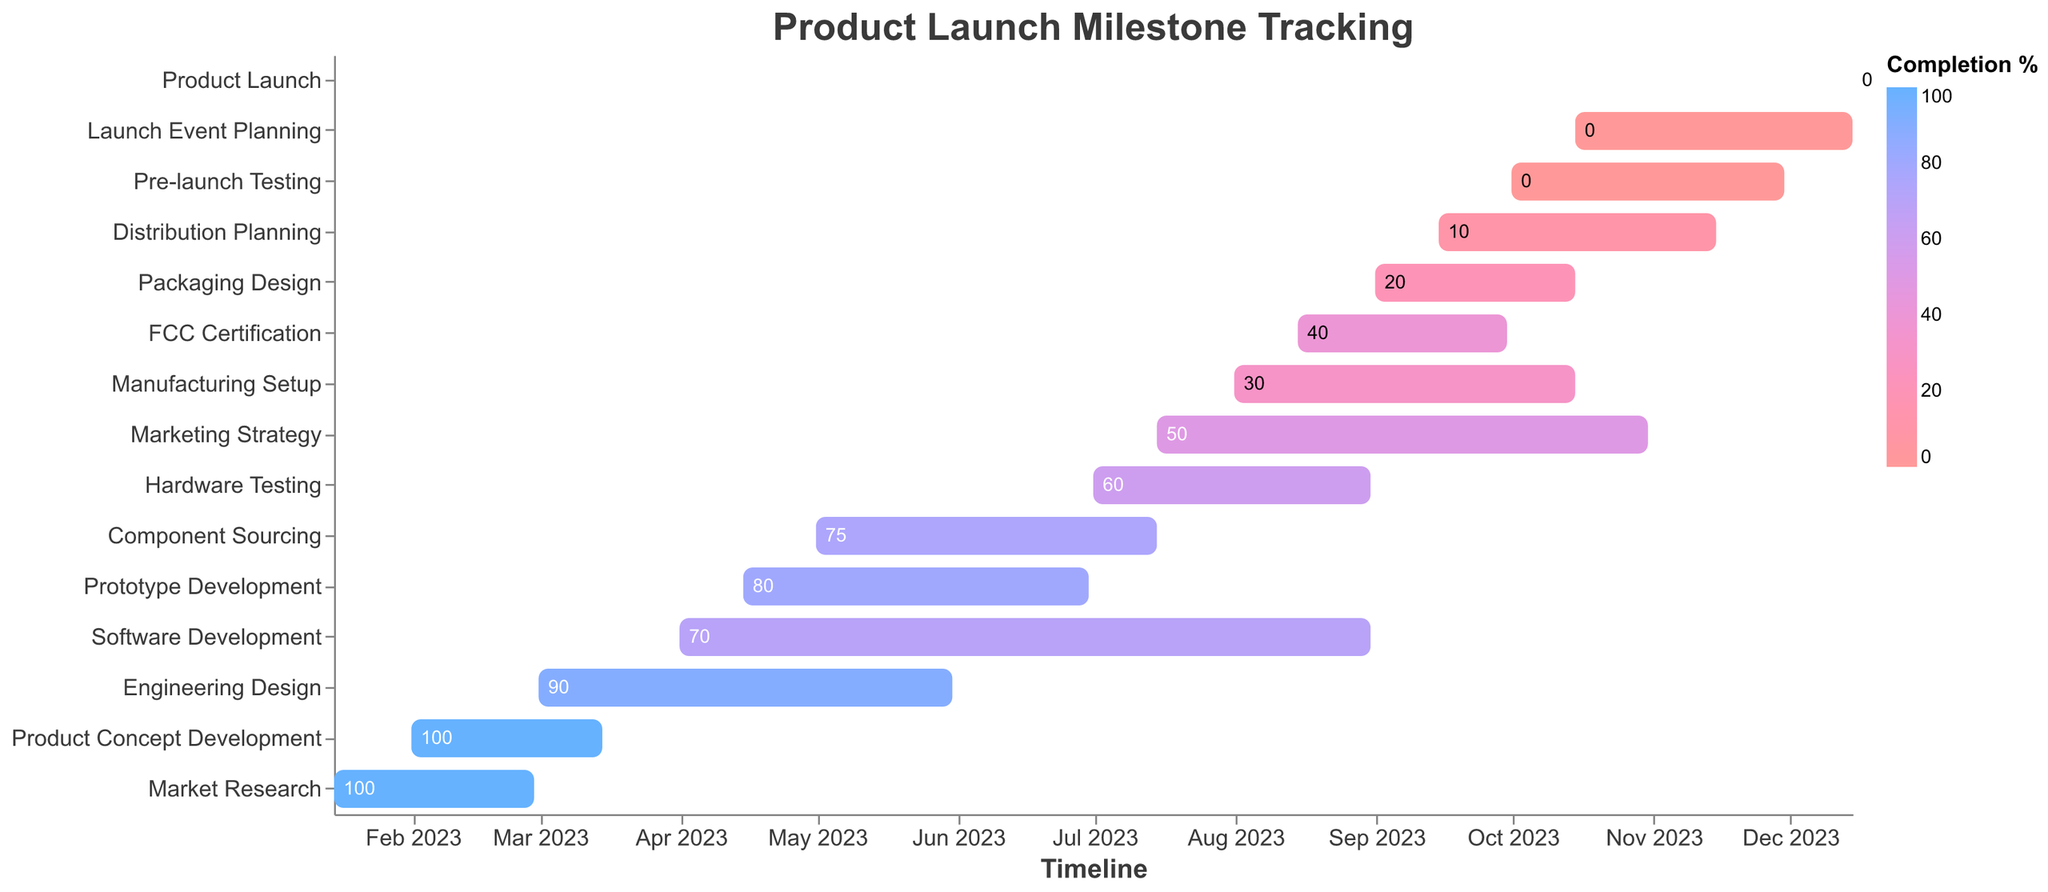What's the title of the figure? The title is displayed prominently at the top of the figure. It serves as a general summary of what the figure represents.
Answer: "Product Launch Milestone Tracking" How many tasks are in the Gantt Chart? Count the number of unique task names listed on the y-axis.
Answer: 15 Which task has the highest completion percentage? Look for the task with the darkest blue color bar, which represents the highest completion percentage.
Answer: Market Research What is the duration of the "Engineering Design" task? Identify the "Engineering Design" task and find its duration on the bar.
Answer: 92 days Which tasks are overlapping in the month of August 2023? Look at the timeline along the x-axis for August 2023 and identify the tasks that have bars spanning this period.
Answer: Software Development, Hardware Testing, FCC Certification, Manufacturing Setup, Marketing Strategy What is the combined duration of "Marketing Strategy" and "Distribution Planning" tasks? Add the duration of "Marketing Strategy" (109 days) and "Distribution Planning" (62 days).
Answer: 171 days Which task has the lowest completion percentage? Look for the task with the lightest color bar, representing the lowest completion percentage.
Answer: Pre-launch Testing, Launch Event Planning, Product Launch Do any tasks start and end in the same month? If so, name one. Identify tasks where the start and end dates fall within the same month.
Answer: "Market Research" (starts and ends in February 2023) Is "Product Launch" dependent on any prior tasks? Identify if "Product Launch" has any predecessors and find tasks ending just before its start date.
Answer: Yes, "Launch Event Planning" Which tasks have a lower completion percentage than "Hardware Testing"? Note the completion percentage for "Hardware Testing" (60%) and identify tasks with a lower percentage by comparing the colors manually.
Answer: FCC Certification, Manufacturing Setup, Packaging Design, Distribution Planning, Pre-launch Testing, Launch Event Planning, Product Launch 